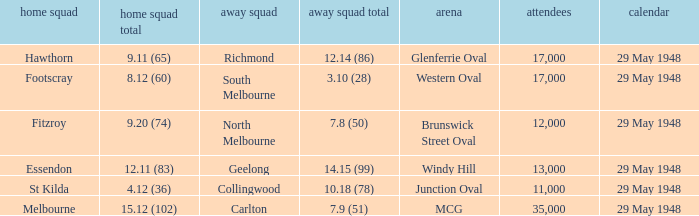During melbourne's home game, who was the away team? Carlton. 